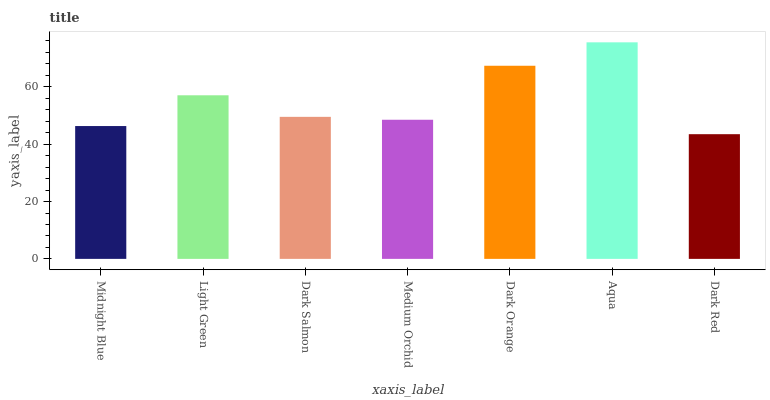Is Dark Red the minimum?
Answer yes or no. Yes. Is Aqua the maximum?
Answer yes or no. Yes. Is Light Green the minimum?
Answer yes or no. No. Is Light Green the maximum?
Answer yes or no. No. Is Light Green greater than Midnight Blue?
Answer yes or no. Yes. Is Midnight Blue less than Light Green?
Answer yes or no. Yes. Is Midnight Blue greater than Light Green?
Answer yes or no. No. Is Light Green less than Midnight Blue?
Answer yes or no. No. Is Dark Salmon the high median?
Answer yes or no. Yes. Is Dark Salmon the low median?
Answer yes or no. Yes. Is Dark Orange the high median?
Answer yes or no. No. Is Medium Orchid the low median?
Answer yes or no. No. 